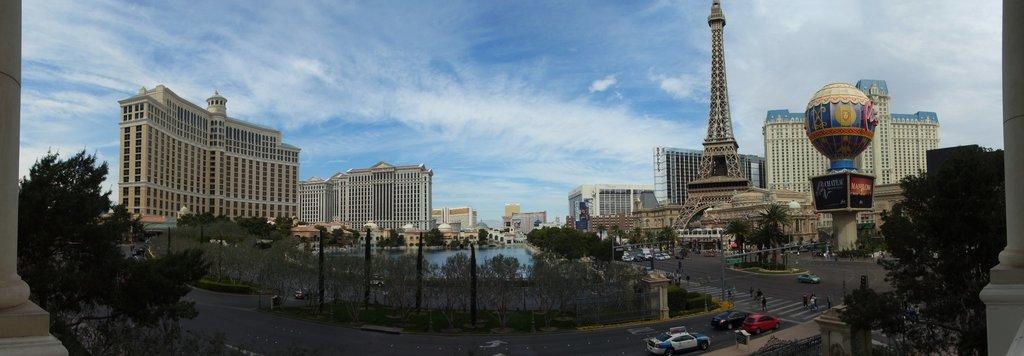How would you summarize this image in a sentence or two? In this image there are tall buildings. On the right side there is Eiffel tower. There is water. There are vehicles moving on the road. There are trees. 